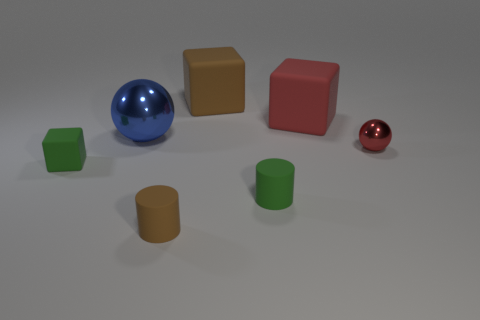Add 1 blue metal balls. How many objects exist? 8 Subtract all brown blocks. How many blocks are left? 2 Subtract 1 cubes. How many cubes are left? 2 Subtract all balls. How many objects are left? 5 Subtract all large metal spheres. Subtract all green matte things. How many objects are left? 4 Add 6 large matte things. How many large matte things are left? 8 Add 3 tiny gray metallic balls. How many tiny gray metallic balls exist? 3 Subtract 1 blue balls. How many objects are left? 6 Subtract all yellow cylinders. Subtract all gray spheres. How many cylinders are left? 2 